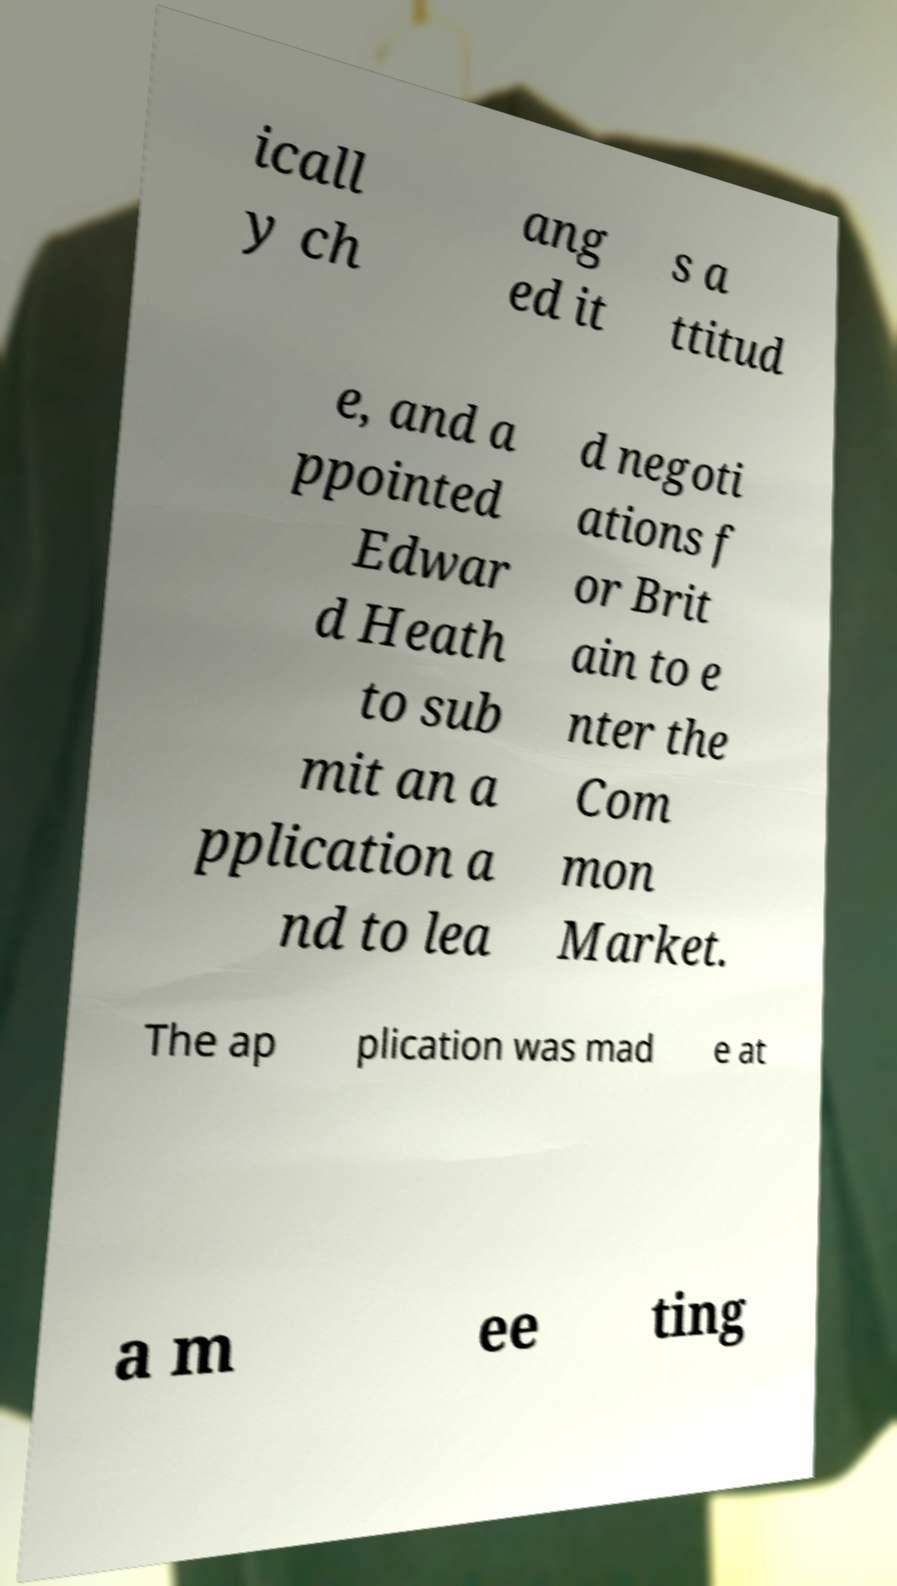Please identify and transcribe the text found in this image. icall y ch ang ed it s a ttitud e, and a ppointed Edwar d Heath to sub mit an a pplication a nd to lea d negoti ations f or Brit ain to e nter the Com mon Market. The ap plication was mad e at a m ee ting 